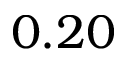Convert formula to latex. <formula><loc_0><loc_0><loc_500><loc_500>0 . 2 0</formula> 